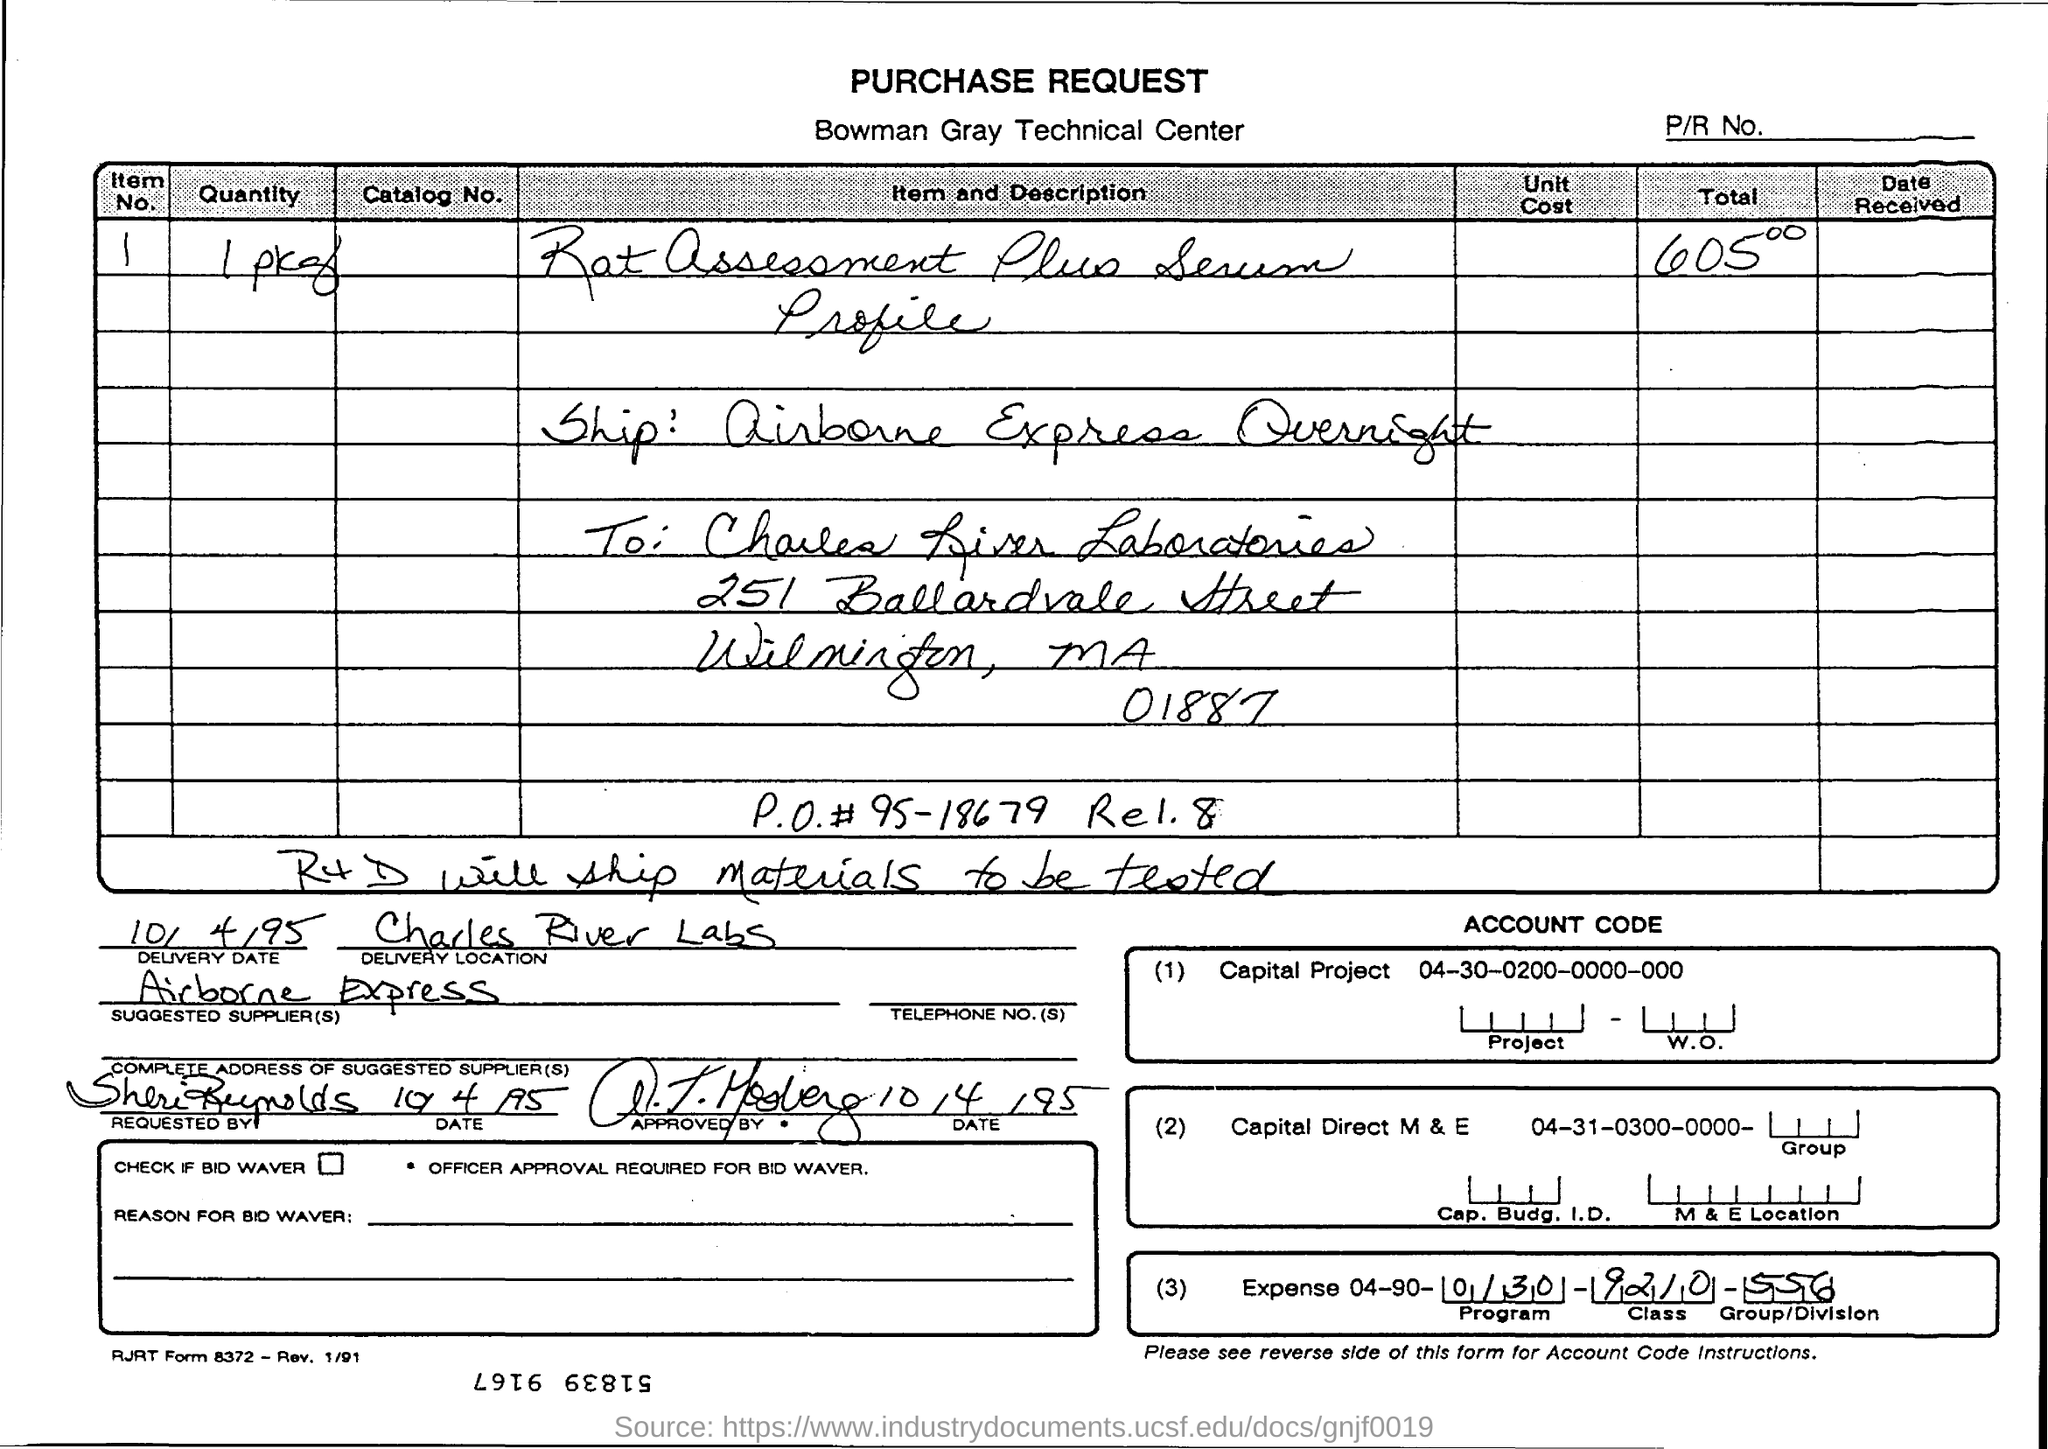What is the name of technical center?
Give a very brief answer. Bowman Gray. 